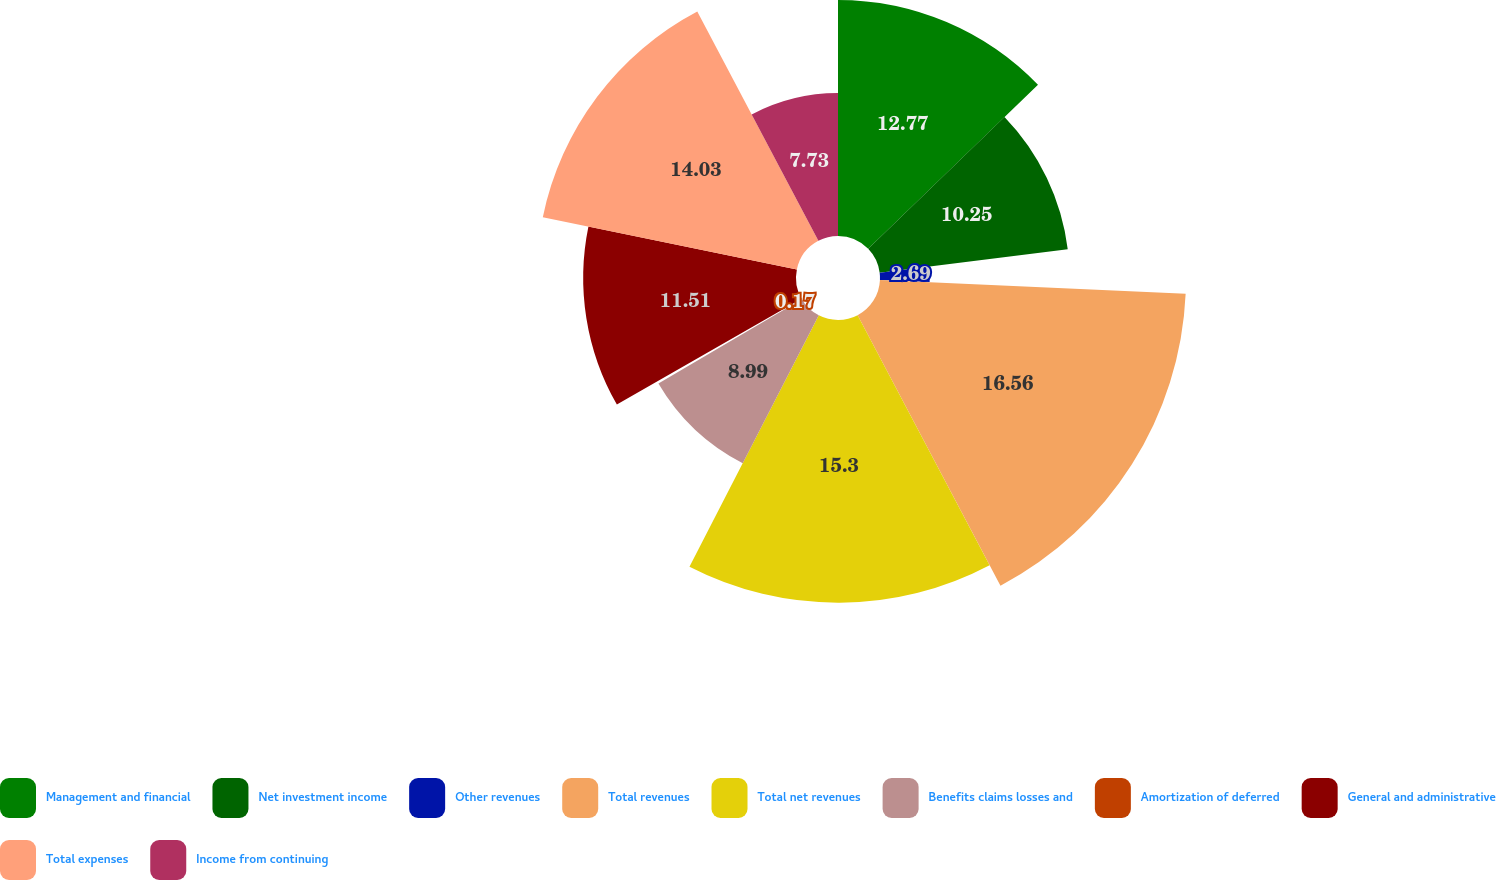Convert chart. <chart><loc_0><loc_0><loc_500><loc_500><pie_chart><fcel>Management and financial<fcel>Net investment income<fcel>Other revenues<fcel>Total revenues<fcel>Total net revenues<fcel>Benefits claims losses and<fcel>Amortization of deferred<fcel>General and administrative<fcel>Total expenses<fcel>Income from continuing<nl><fcel>12.77%<fcel>10.25%<fcel>2.69%<fcel>16.55%<fcel>15.29%<fcel>8.99%<fcel>0.17%<fcel>11.51%<fcel>14.03%<fcel>7.73%<nl></chart> 